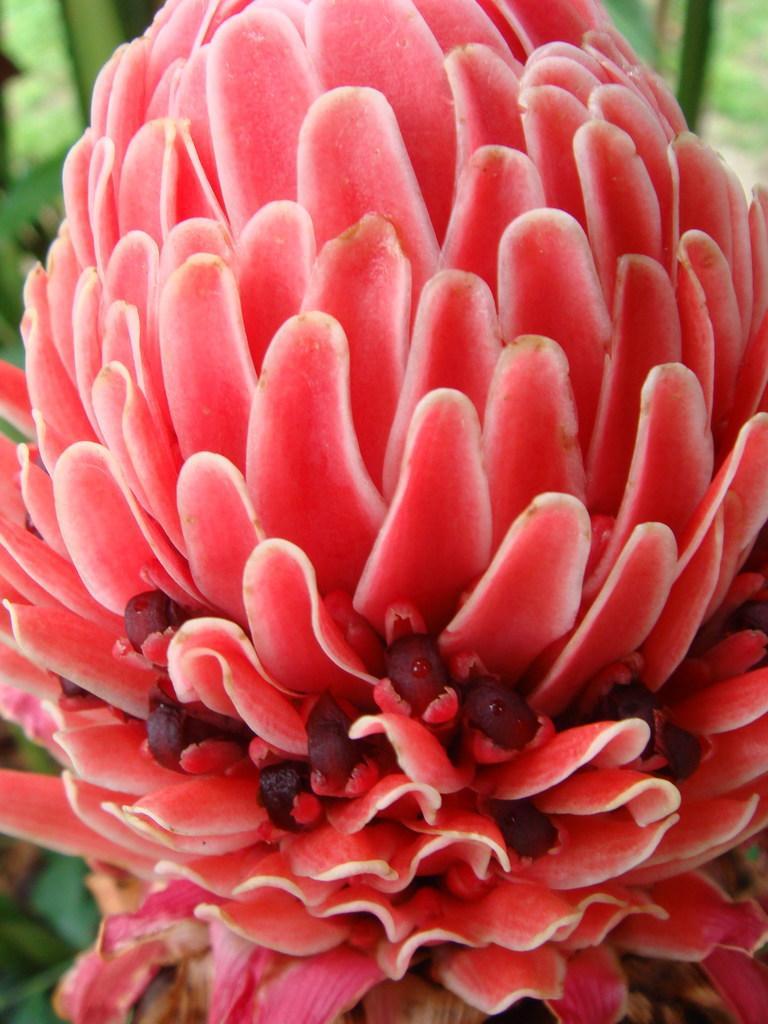Please provide a concise description of this image. Here I can see a flower, its petals are in red color. In the background few leaves are visible. 